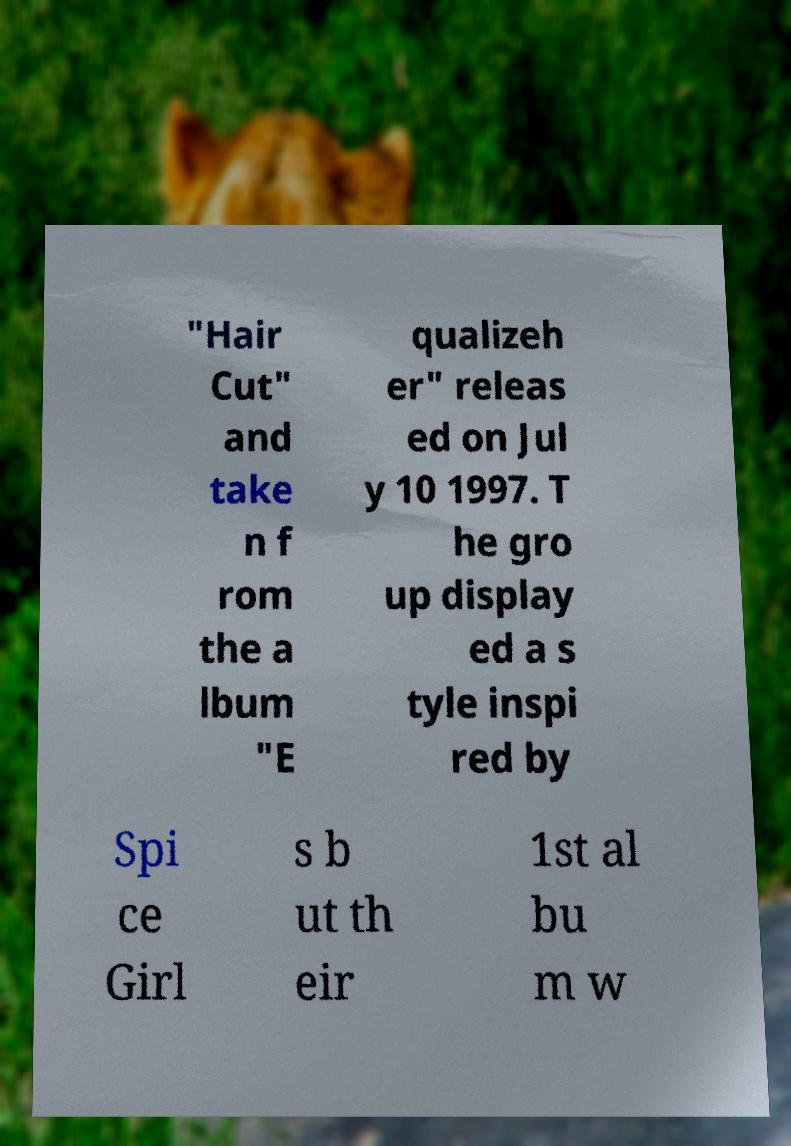Can you read and provide the text displayed in the image?This photo seems to have some interesting text. Can you extract and type it out for me? "Hair Cut" and take n f rom the a lbum "E qualizeh er" releas ed on Jul y 10 1997. T he gro up display ed a s tyle inspi red by Spi ce Girl s b ut th eir 1st al bu m w 